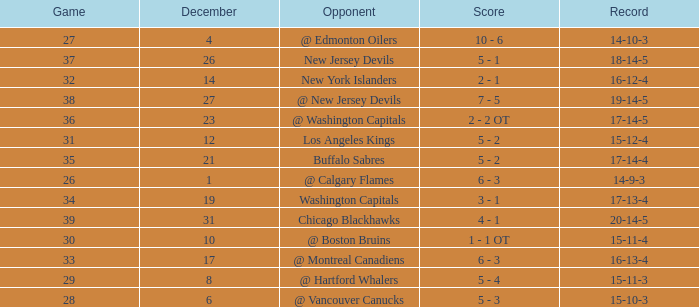Record of 15-12-4, and a Game larger than 31 involves what highest December? None. 